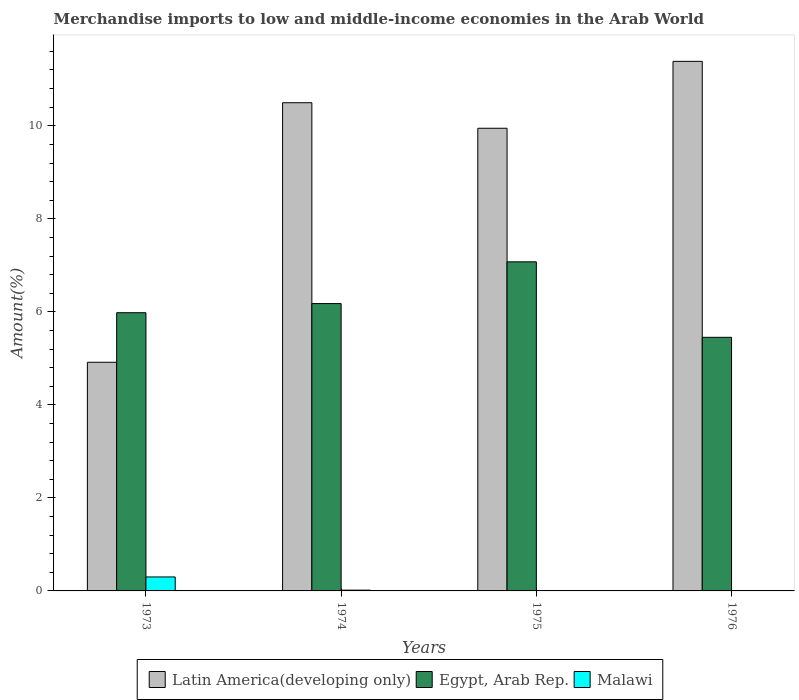How many groups of bars are there?
Provide a succinct answer. 4. Are the number of bars per tick equal to the number of legend labels?
Your answer should be compact. Yes. Are the number of bars on each tick of the X-axis equal?
Keep it short and to the point. Yes. How many bars are there on the 1st tick from the left?
Your answer should be compact. 3. What is the percentage of amount earned from merchandise imports in Latin America(developing only) in 1976?
Your answer should be very brief. 11.39. Across all years, what is the maximum percentage of amount earned from merchandise imports in Malawi?
Offer a terse response. 0.3. Across all years, what is the minimum percentage of amount earned from merchandise imports in Latin America(developing only)?
Make the answer very short. 4.92. In which year was the percentage of amount earned from merchandise imports in Egypt, Arab Rep. maximum?
Your answer should be very brief. 1975. In which year was the percentage of amount earned from merchandise imports in Malawi minimum?
Your response must be concise. 1976. What is the total percentage of amount earned from merchandise imports in Latin America(developing only) in the graph?
Provide a short and direct response. 36.75. What is the difference between the percentage of amount earned from merchandise imports in Latin America(developing only) in 1973 and that in 1975?
Your answer should be very brief. -5.03. What is the difference between the percentage of amount earned from merchandise imports in Latin America(developing only) in 1975 and the percentage of amount earned from merchandise imports in Egypt, Arab Rep. in 1974?
Provide a succinct answer. 3.77. What is the average percentage of amount earned from merchandise imports in Malawi per year?
Provide a short and direct response. 0.08. In the year 1976, what is the difference between the percentage of amount earned from merchandise imports in Latin America(developing only) and percentage of amount earned from merchandise imports in Egypt, Arab Rep.?
Offer a very short reply. 5.93. What is the ratio of the percentage of amount earned from merchandise imports in Egypt, Arab Rep. in 1973 to that in 1975?
Your answer should be compact. 0.85. What is the difference between the highest and the second highest percentage of amount earned from merchandise imports in Malawi?
Keep it short and to the point. 0.28. What is the difference between the highest and the lowest percentage of amount earned from merchandise imports in Latin America(developing only)?
Your answer should be very brief. 6.47. What does the 2nd bar from the left in 1973 represents?
Keep it short and to the point. Egypt, Arab Rep. What does the 1st bar from the right in 1975 represents?
Make the answer very short. Malawi. Does the graph contain grids?
Ensure brevity in your answer.  No. Where does the legend appear in the graph?
Your answer should be compact. Bottom center. How many legend labels are there?
Your answer should be very brief. 3. What is the title of the graph?
Ensure brevity in your answer.  Merchandise imports to low and middle-income economies in the Arab World. What is the label or title of the X-axis?
Keep it short and to the point. Years. What is the label or title of the Y-axis?
Provide a short and direct response. Amount(%). What is the Amount(%) of Latin America(developing only) in 1973?
Give a very brief answer. 4.92. What is the Amount(%) in Egypt, Arab Rep. in 1973?
Keep it short and to the point. 5.98. What is the Amount(%) of Malawi in 1973?
Offer a terse response. 0.3. What is the Amount(%) of Latin America(developing only) in 1974?
Provide a succinct answer. 10.5. What is the Amount(%) of Egypt, Arab Rep. in 1974?
Make the answer very short. 6.18. What is the Amount(%) in Malawi in 1974?
Ensure brevity in your answer.  0.02. What is the Amount(%) of Latin America(developing only) in 1975?
Offer a terse response. 9.95. What is the Amount(%) in Egypt, Arab Rep. in 1975?
Keep it short and to the point. 7.08. What is the Amount(%) of Malawi in 1975?
Provide a succinct answer. 0.01. What is the Amount(%) in Latin America(developing only) in 1976?
Provide a succinct answer. 11.39. What is the Amount(%) in Egypt, Arab Rep. in 1976?
Provide a succinct answer. 5.45. What is the Amount(%) of Malawi in 1976?
Make the answer very short. 0. Across all years, what is the maximum Amount(%) in Latin America(developing only)?
Provide a succinct answer. 11.39. Across all years, what is the maximum Amount(%) of Egypt, Arab Rep.?
Provide a succinct answer. 7.08. Across all years, what is the maximum Amount(%) in Malawi?
Make the answer very short. 0.3. Across all years, what is the minimum Amount(%) in Latin America(developing only)?
Make the answer very short. 4.92. Across all years, what is the minimum Amount(%) in Egypt, Arab Rep.?
Your answer should be compact. 5.45. Across all years, what is the minimum Amount(%) of Malawi?
Provide a short and direct response. 0. What is the total Amount(%) of Latin America(developing only) in the graph?
Offer a terse response. 36.75. What is the total Amount(%) of Egypt, Arab Rep. in the graph?
Keep it short and to the point. 24.69. What is the total Amount(%) of Malawi in the graph?
Keep it short and to the point. 0.33. What is the difference between the Amount(%) of Latin America(developing only) in 1973 and that in 1974?
Provide a succinct answer. -5.58. What is the difference between the Amount(%) of Egypt, Arab Rep. in 1973 and that in 1974?
Provide a succinct answer. -0.2. What is the difference between the Amount(%) in Malawi in 1973 and that in 1974?
Offer a very short reply. 0.28. What is the difference between the Amount(%) in Latin America(developing only) in 1973 and that in 1975?
Your response must be concise. -5.03. What is the difference between the Amount(%) in Egypt, Arab Rep. in 1973 and that in 1975?
Provide a short and direct response. -1.09. What is the difference between the Amount(%) of Malawi in 1973 and that in 1975?
Ensure brevity in your answer.  0.29. What is the difference between the Amount(%) in Latin America(developing only) in 1973 and that in 1976?
Your answer should be compact. -6.47. What is the difference between the Amount(%) in Egypt, Arab Rep. in 1973 and that in 1976?
Your response must be concise. 0.53. What is the difference between the Amount(%) of Malawi in 1973 and that in 1976?
Provide a succinct answer. 0.3. What is the difference between the Amount(%) in Latin America(developing only) in 1974 and that in 1975?
Your answer should be compact. 0.55. What is the difference between the Amount(%) in Egypt, Arab Rep. in 1974 and that in 1975?
Make the answer very short. -0.9. What is the difference between the Amount(%) in Malawi in 1974 and that in 1975?
Keep it short and to the point. 0.01. What is the difference between the Amount(%) of Latin America(developing only) in 1974 and that in 1976?
Your answer should be compact. -0.89. What is the difference between the Amount(%) in Egypt, Arab Rep. in 1974 and that in 1976?
Make the answer very short. 0.73. What is the difference between the Amount(%) in Malawi in 1974 and that in 1976?
Offer a terse response. 0.01. What is the difference between the Amount(%) of Latin America(developing only) in 1975 and that in 1976?
Keep it short and to the point. -1.44. What is the difference between the Amount(%) of Egypt, Arab Rep. in 1975 and that in 1976?
Ensure brevity in your answer.  1.62. What is the difference between the Amount(%) in Malawi in 1975 and that in 1976?
Offer a terse response. 0.01. What is the difference between the Amount(%) of Latin America(developing only) in 1973 and the Amount(%) of Egypt, Arab Rep. in 1974?
Offer a very short reply. -1.26. What is the difference between the Amount(%) in Latin America(developing only) in 1973 and the Amount(%) in Malawi in 1974?
Provide a succinct answer. 4.9. What is the difference between the Amount(%) in Egypt, Arab Rep. in 1973 and the Amount(%) in Malawi in 1974?
Offer a terse response. 5.96. What is the difference between the Amount(%) in Latin America(developing only) in 1973 and the Amount(%) in Egypt, Arab Rep. in 1975?
Your answer should be very brief. -2.16. What is the difference between the Amount(%) in Latin America(developing only) in 1973 and the Amount(%) in Malawi in 1975?
Your answer should be compact. 4.91. What is the difference between the Amount(%) of Egypt, Arab Rep. in 1973 and the Amount(%) of Malawi in 1975?
Ensure brevity in your answer.  5.97. What is the difference between the Amount(%) in Latin America(developing only) in 1973 and the Amount(%) in Egypt, Arab Rep. in 1976?
Provide a succinct answer. -0.54. What is the difference between the Amount(%) of Latin America(developing only) in 1973 and the Amount(%) of Malawi in 1976?
Your response must be concise. 4.91. What is the difference between the Amount(%) in Egypt, Arab Rep. in 1973 and the Amount(%) in Malawi in 1976?
Provide a short and direct response. 5.98. What is the difference between the Amount(%) in Latin America(developing only) in 1974 and the Amount(%) in Egypt, Arab Rep. in 1975?
Your answer should be compact. 3.42. What is the difference between the Amount(%) in Latin America(developing only) in 1974 and the Amount(%) in Malawi in 1975?
Your response must be concise. 10.49. What is the difference between the Amount(%) of Egypt, Arab Rep. in 1974 and the Amount(%) of Malawi in 1975?
Offer a very short reply. 6.17. What is the difference between the Amount(%) in Latin America(developing only) in 1974 and the Amount(%) in Egypt, Arab Rep. in 1976?
Offer a very short reply. 5.04. What is the difference between the Amount(%) of Latin America(developing only) in 1974 and the Amount(%) of Malawi in 1976?
Your answer should be very brief. 10.49. What is the difference between the Amount(%) in Egypt, Arab Rep. in 1974 and the Amount(%) in Malawi in 1976?
Offer a very short reply. 6.18. What is the difference between the Amount(%) of Latin America(developing only) in 1975 and the Amount(%) of Egypt, Arab Rep. in 1976?
Give a very brief answer. 4.5. What is the difference between the Amount(%) of Latin America(developing only) in 1975 and the Amount(%) of Malawi in 1976?
Your answer should be very brief. 9.95. What is the difference between the Amount(%) of Egypt, Arab Rep. in 1975 and the Amount(%) of Malawi in 1976?
Provide a short and direct response. 7.07. What is the average Amount(%) of Latin America(developing only) per year?
Keep it short and to the point. 9.19. What is the average Amount(%) in Egypt, Arab Rep. per year?
Offer a terse response. 6.17. What is the average Amount(%) in Malawi per year?
Ensure brevity in your answer.  0.08. In the year 1973, what is the difference between the Amount(%) of Latin America(developing only) and Amount(%) of Egypt, Arab Rep.?
Provide a succinct answer. -1.07. In the year 1973, what is the difference between the Amount(%) of Latin America(developing only) and Amount(%) of Malawi?
Make the answer very short. 4.62. In the year 1973, what is the difference between the Amount(%) of Egypt, Arab Rep. and Amount(%) of Malawi?
Your answer should be very brief. 5.68. In the year 1974, what is the difference between the Amount(%) in Latin America(developing only) and Amount(%) in Egypt, Arab Rep.?
Offer a very short reply. 4.32. In the year 1974, what is the difference between the Amount(%) of Latin America(developing only) and Amount(%) of Malawi?
Your response must be concise. 10.48. In the year 1974, what is the difference between the Amount(%) of Egypt, Arab Rep. and Amount(%) of Malawi?
Provide a short and direct response. 6.16. In the year 1975, what is the difference between the Amount(%) in Latin America(developing only) and Amount(%) in Egypt, Arab Rep.?
Your response must be concise. 2.87. In the year 1975, what is the difference between the Amount(%) of Latin America(developing only) and Amount(%) of Malawi?
Give a very brief answer. 9.94. In the year 1975, what is the difference between the Amount(%) in Egypt, Arab Rep. and Amount(%) in Malawi?
Ensure brevity in your answer.  7.07. In the year 1976, what is the difference between the Amount(%) in Latin America(developing only) and Amount(%) in Egypt, Arab Rep.?
Ensure brevity in your answer.  5.93. In the year 1976, what is the difference between the Amount(%) of Latin America(developing only) and Amount(%) of Malawi?
Ensure brevity in your answer.  11.38. In the year 1976, what is the difference between the Amount(%) of Egypt, Arab Rep. and Amount(%) of Malawi?
Ensure brevity in your answer.  5.45. What is the ratio of the Amount(%) of Latin America(developing only) in 1973 to that in 1974?
Your response must be concise. 0.47. What is the ratio of the Amount(%) of Egypt, Arab Rep. in 1973 to that in 1974?
Your answer should be compact. 0.97. What is the ratio of the Amount(%) of Malawi in 1973 to that in 1974?
Give a very brief answer. 18.2. What is the ratio of the Amount(%) in Latin America(developing only) in 1973 to that in 1975?
Offer a terse response. 0.49. What is the ratio of the Amount(%) in Egypt, Arab Rep. in 1973 to that in 1975?
Your answer should be very brief. 0.85. What is the ratio of the Amount(%) of Malawi in 1973 to that in 1975?
Keep it short and to the point. 34.13. What is the ratio of the Amount(%) of Latin America(developing only) in 1973 to that in 1976?
Your answer should be very brief. 0.43. What is the ratio of the Amount(%) of Egypt, Arab Rep. in 1973 to that in 1976?
Your answer should be very brief. 1.1. What is the ratio of the Amount(%) of Malawi in 1973 to that in 1976?
Offer a very short reply. 205.98. What is the ratio of the Amount(%) in Latin America(developing only) in 1974 to that in 1975?
Provide a short and direct response. 1.06. What is the ratio of the Amount(%) in Egypt, Arab Rep. in 1974 to that in 1975?
Offer a very short reply. 0.87. What is the ratio of the Amount(%) of Malawi in 1974 to that in 1975?
Keep it short and to the point. 1.88. What is the ratio of the Amount(%) in Latin America(developing only) in 1974 to that in 1976?
Give a very brief answer. 0.92. What is the ratio of the Amount(%) in Egypt, Arab Rep. in 1974 to that in 1976?
Provide a succinct answer. 1.13. What is the ratio of the Amount(%) of Malawi in 1974 to that in 1976?
Your response must be concise. 11.32. What is the ratio of the Amount(%) in Latin America(developing only) in 1975 to that in 1976?
Offer a very short reply. 0.87. What is the ratio of the Amount(%) of Egypt, Arab Rep. in 1975 to that in 1976?
Provide a succinct answer. 1.3. What is the ratio of the Amount(%) in Malawi in 1975 to that in 1976?
Make the answer very short. 6.03. What is the difference between the highest and the second highest Amount(%) in Latin America(developing only)?
Provide a short and direct response. 0.89. What is the difference between the highest and the second highest Amount(%) in Egypt, Arab Rep.?
Provide a short and direct response. 0.9. What is the difference between the highest and the second highest Amount(%) in Malawi?
Keep it short and to the point. 0.28. What is the difference between the highest and the lowest Amount(%) of Latin America(developing only)?
Offer a terse response. 6.47. What is the difference between the highest and the lowest Amount(%) of Egypt, Arab Rep.?
Your response must be concise. 1.62. What is the difference between the highest and the lowest Amount(%) of Malawi?
Offer a very short reply. 0.3. 